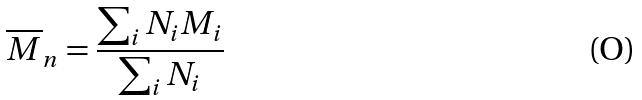Convert formula to latex. <formula><loc_0><loc_0><loc_500><loc_500>\overline { M } _ { n } = \frac { \sum _ { i } N _ { i } M _ { i } } { \sum _ { i } N _ { i } }</formula> 